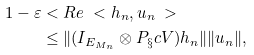<formula> <loc_0><loc_0><loc_500><loc_500>1 - \varepsilon & < R e \ < h _ { n } , u _ { n } \ > \\ & \leq \| ( I _ { E _ { M _ { n } } } \otimes P _ { \S } c { V } ) h _ { n } \| \| u _ { n } \| ,</formula> 